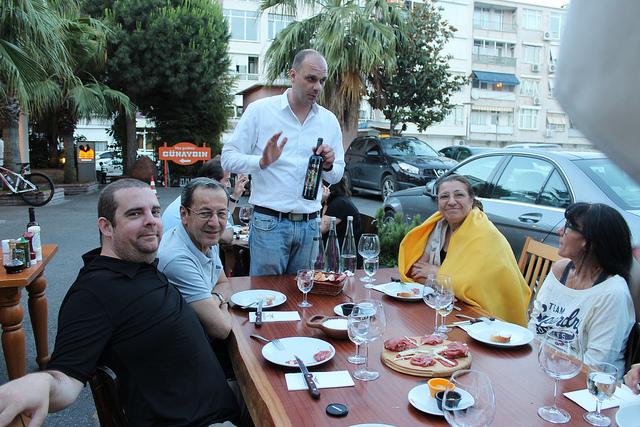How many people are in the picture?
Short answer required. 5. What season is it?
Answer briefly. Spring. What is outside?
Write a very short answer. Cars. Are they eating?
Short answer required. Yes. What color is the knife handle?
Concise answer only. Brown. Are they eating outside?
Answer briefly. Yes. Are these people related?
Quick response, please. Yes. What is the person sitting on?
Answer briefly. Chair. What is the race of the people at the table?
Keep it brief. White. Do these people look happy?
Short answer required. Yes. Where is the chefs knife?
Be succinct. On table. How many glasses are in front of each person?
Concise answer only. 2. Are there any motorcycles?
Concise answer only. No. What is in the cup?
Give a very brief answer. Water. What are we celebrating?
Quick response, please. Birthday. Is this a sit down restaurant?
Short answer required. Yes. 